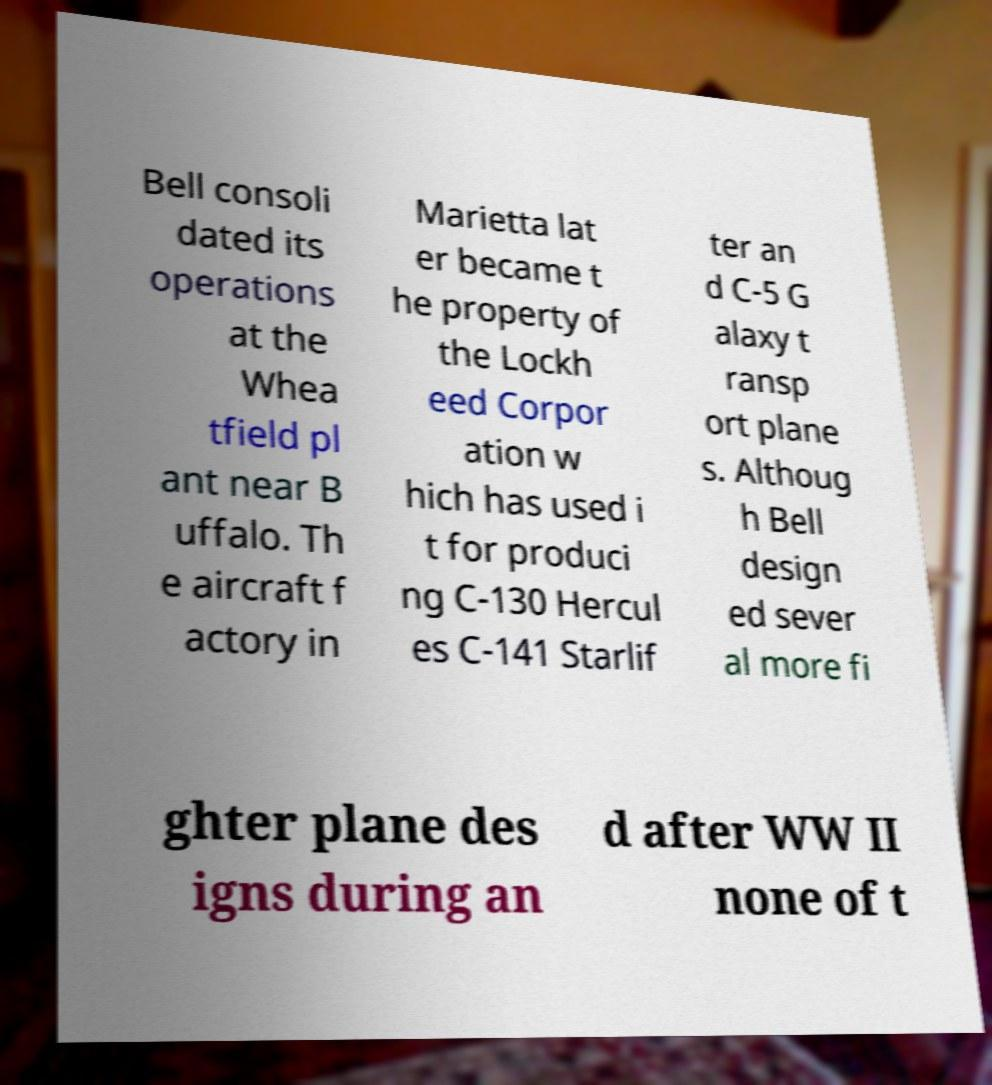There's text embedded in this image that I need extracted. Can you transcribe it verbatim? Bell consoli dated its operations at the Whea tfield pl ant near B uffalo. Th e aircraft f actory in Marietta lat er became t he property of the Lockh eed Corpor ation w hich has used i t for produci ng C-130 Hercul es C-141 Starlif ter an d C-5 G alaxy t ransp ort plane s. Althoug h Bell design ed sever al more fi ghter plane des igns during an d after WW II none of t 